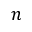<formula> <loc_0><loc_0><loc_500><loc_500>n</formula> 